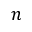<formula> <loc_0><loc_0><loc_500><loc_500>n</formula> 